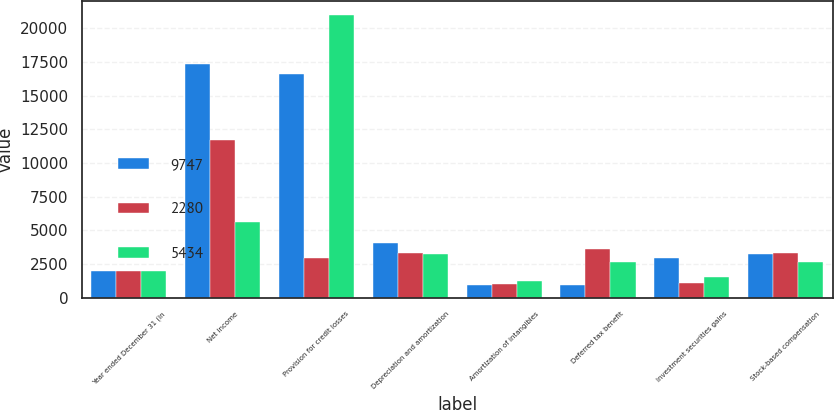Convert chart. <chart><loc_0><loc_0><loc_500><loc_500><stacked_bar_chart><ecel><fcel>Year ended December 31 (in<fcel>Net income<fcel>Provision for credit losses<fcel>Depreciation and amortization<fcel>Amortization of intangibles<fcel>Deferred tax benefit<fcel>Investment securities gains<fcel>Stock-based compensation<nl><fcel>9747<fcel>2010<fcel>17370<fcel>16639<fcel>4029<fcel>936<fcel>968<fcel>2965<fcel>3251<nl><fcel>2280<fcel>2009<fcel>11728<fcel>2965<fcel>3308<fcel>1050<fcel>3622<fcel>1110<fcel>3355<nl><fcel>5434<fcel>2008<fcel>5605<fcel>20979<fcel>3265<fcel>1263<fcel>2637<fcel>1560<fcel>2637<nl></chart> 